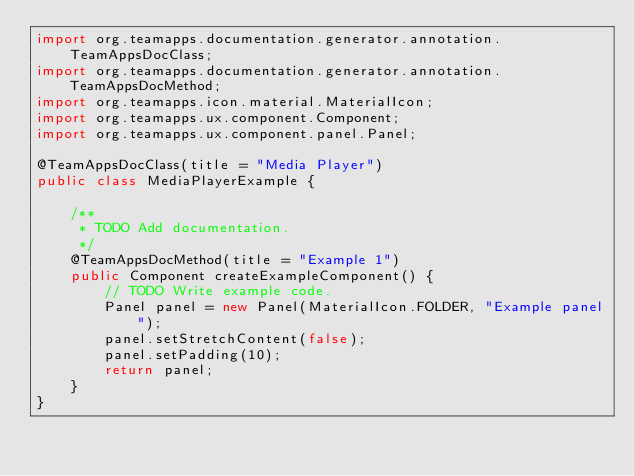<code> <loc_0><loc_0><loc_500><loc_500><_Java_>import org.teamapps.documentation.generator.annotation.TeamAppsDocClass;
import org.teamapps.documentation.generator.annotation.TeamAppsDocMethod;
import org.teamapps.icon.material.MaterialIcon;
import org.teamapps.ux.component.Component;
import org.teamapps.ux.component.panel.Panel;

@TeamAppsDocClass(title = "Media Player")
public class MediaPlayerExample {

	/**
	 * TODO Add documentation.
	 */
	@TeamAppsDocMethod(title = "Example 1")
	public Component createExampleComponent() {
		// TODO Write example code.
		Panel panel = new Panel(MaterialIcon.FOLDER, "Example panel");
		panel.setStretchContent(false);
		panel.setPadding(10);
		return panel;
	}
}
</code> 